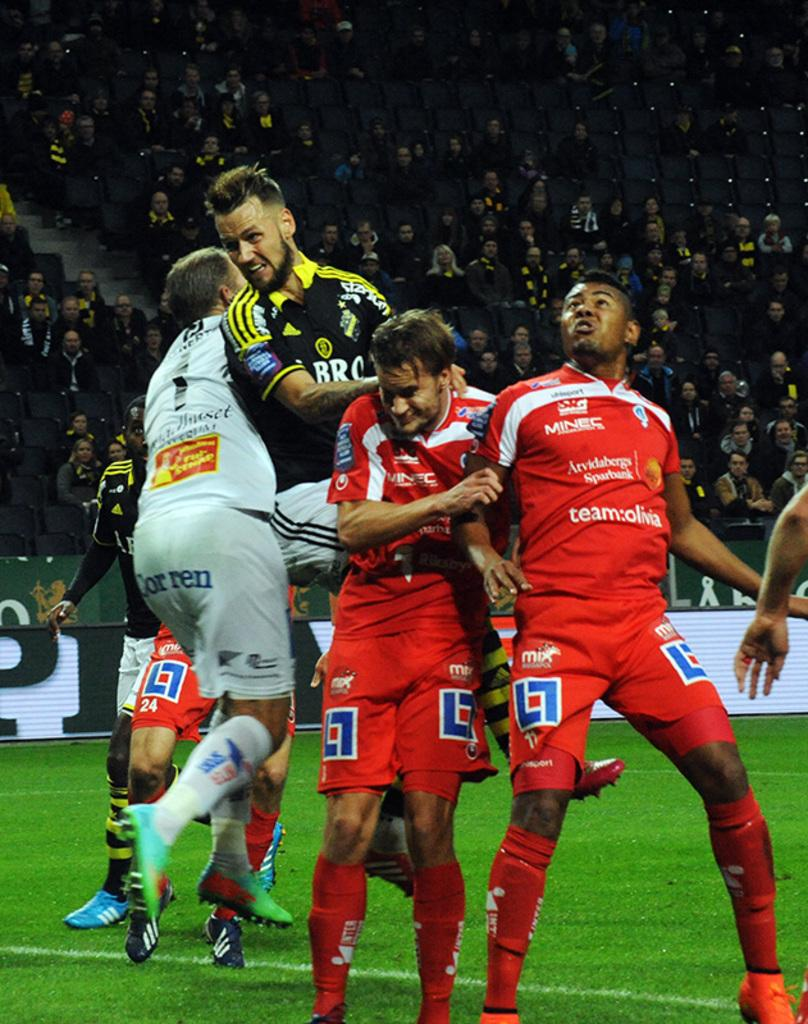Provide a one-sentence caption for the provided image. a group of soccer players, opne with shorts that say mix on them. 